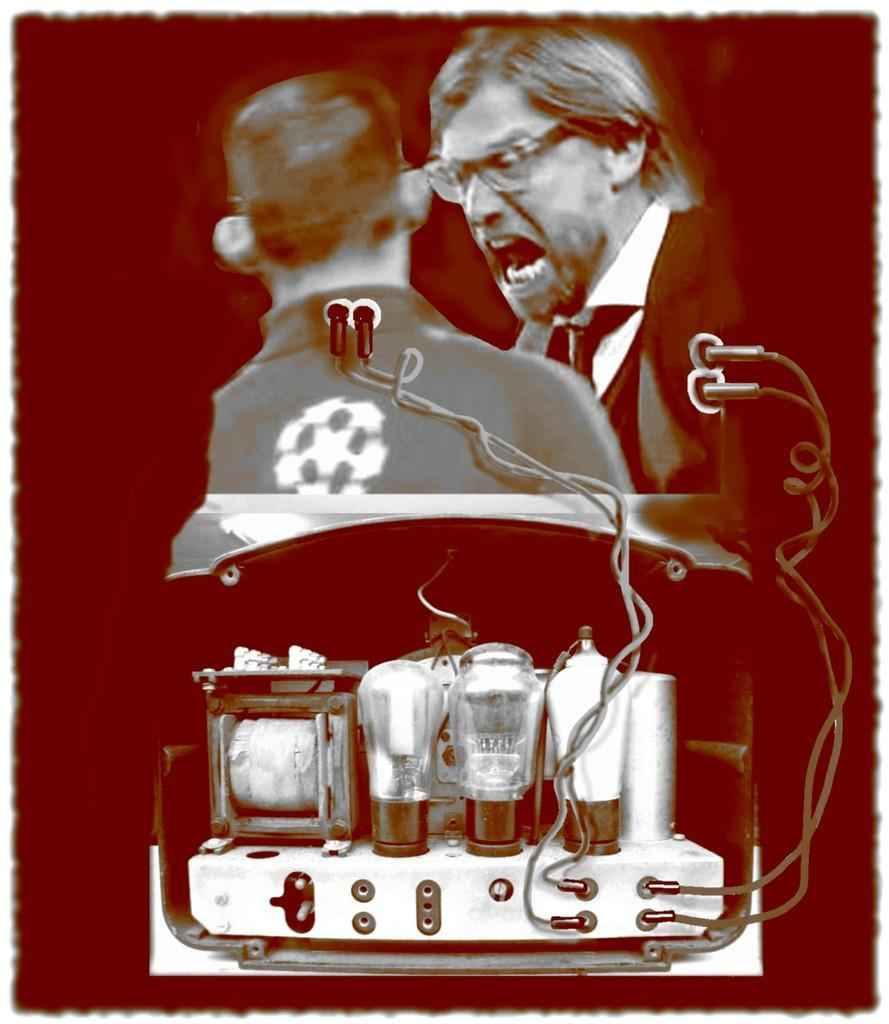What type of objects are present in the image? There are electrical instruments in the image. How many people are visible in the image? There are two people in the animated image. What can be said about the background of the image? The background of the image is dark. What part of the electrical instruments is on fire in the image? There is no fire or burning component in the image; the electrical instruments are not depicted as being damaged or on fire. 